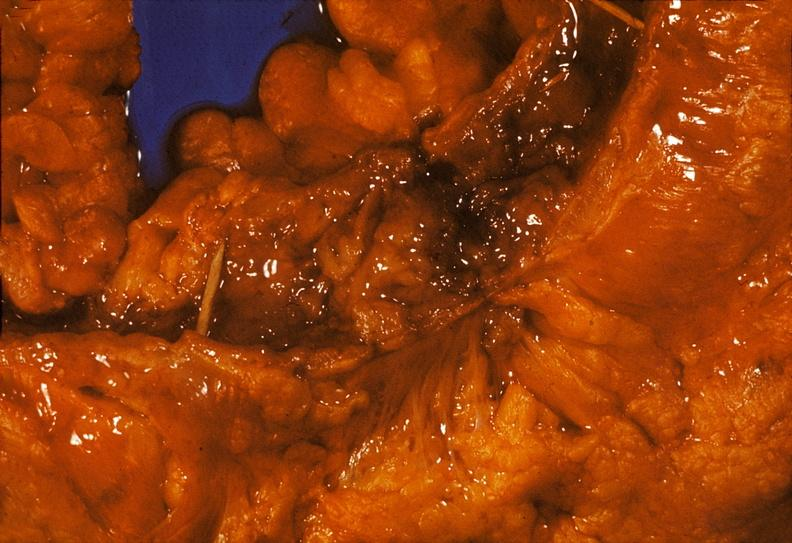s gastrointestinal present?
Answer the question using a single word or phrase. Yes 